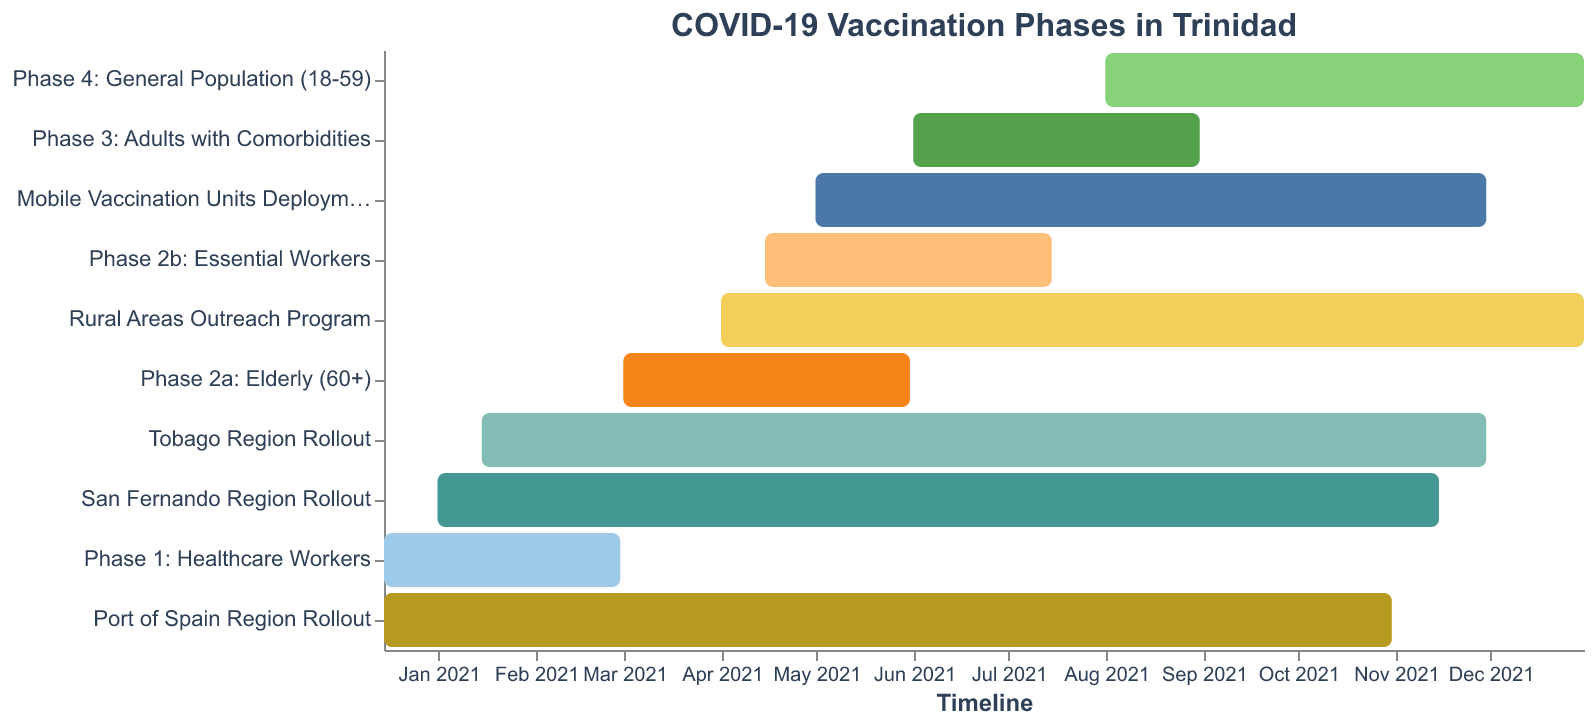How many phases of the COVID-19 vaccination are shown? The Gantt chart lists the phases as tasks, each starting and ending at specific times. Count the number of tasks labeled as phases.
Answer: 5 When did the rollout in Port of Spain begin and end? Find the task 'Port of Spain Region Rollout' and check the start and end dates.
Answer: December 15, 2020 to October 31, 2021 Which phase continued for the longest period? Compare the durations of all phases by subtracting the start date from the end date for each phase and observe which has the greatest interval.
Answer: Phase 4: General Population (18-59) Which vaccination phase overlaps with the deployment of Mobile Vaccination Units? Identify the phases that have start and end dates that fall within the range of the Mobile Vaccination Units Deployment (May 01, 2021 to November 30, 2021).
Answer: Phase 2b, Phase 3, and Phase 4 How many vaccination phases started after May 2021? Examine the start date of each phase and count those that commence after May 2021.
Answer: 2 What is the total duration of vaccinations for adults with comorbidities? Subtract the start date (June 01, 2021) from the end date (August 31, 2021) to find the duration.
Answer: 3 months Which two regional rollouts have the most overlap in their schedules? Compare the start and end dates of each regional rollout to find the pair with the most overlapping days.
Answer: San Fernando Region and Tobago Region Did the Rural Areas Outreach Program start before or after Phase 2b? Compare the start dates of the Rural Areas Outreach Program (April 01, 2021) and Phase 2b (April 15, 2021).
Answer: Before What is the difference in duration between Phase 2a and Phase 2b? Calculate the duration of Phase 2a (March 01, 2021 to May 31, 2021) and Phase 2b (April 15, 2021 to July 15, 2021), then find the difference between these durations.
Answer: 1 month 